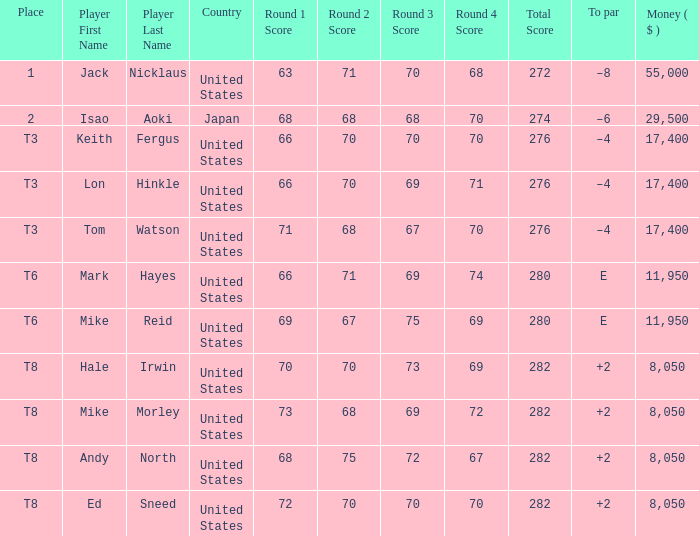What player has money larger than 11,950 and is placed in t8 and has the score of 73-68-69-72=282? None. 